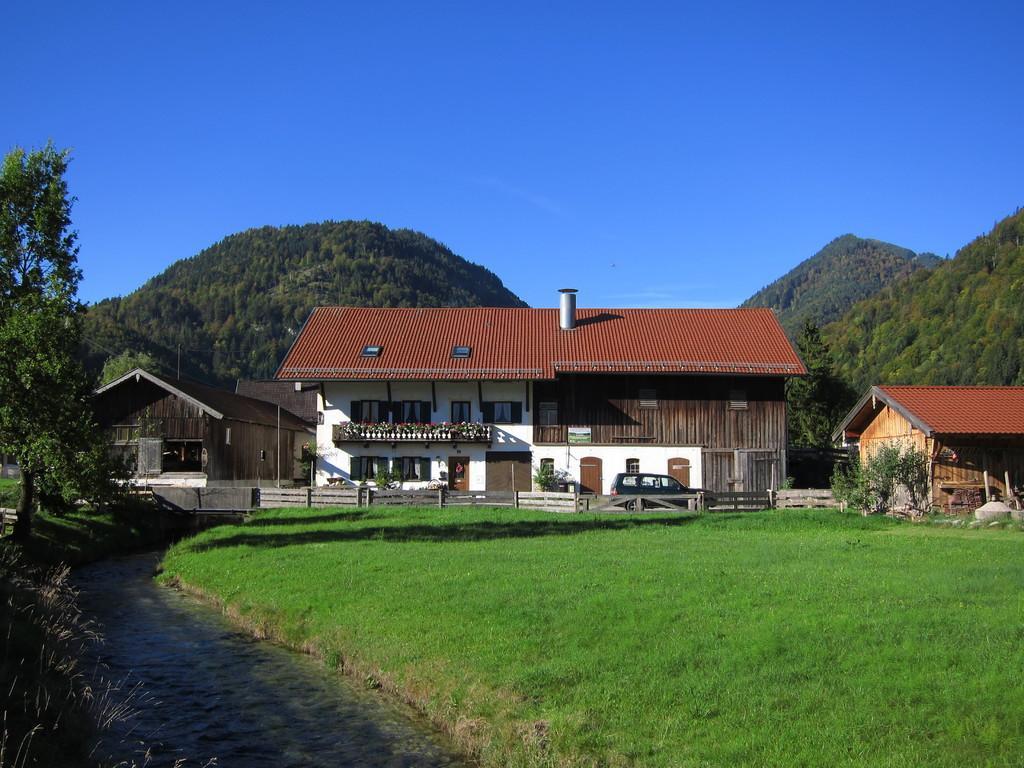In one or two sentences, can you explain what this image depicts? In this image we can see houses. In front of the houses we can see a vehicle, plants, wooden fencing and the grass. On the left side we can see the grass and trees. Behind the houses we can see the mountains and a group of trees. At the top we can see the sky. 